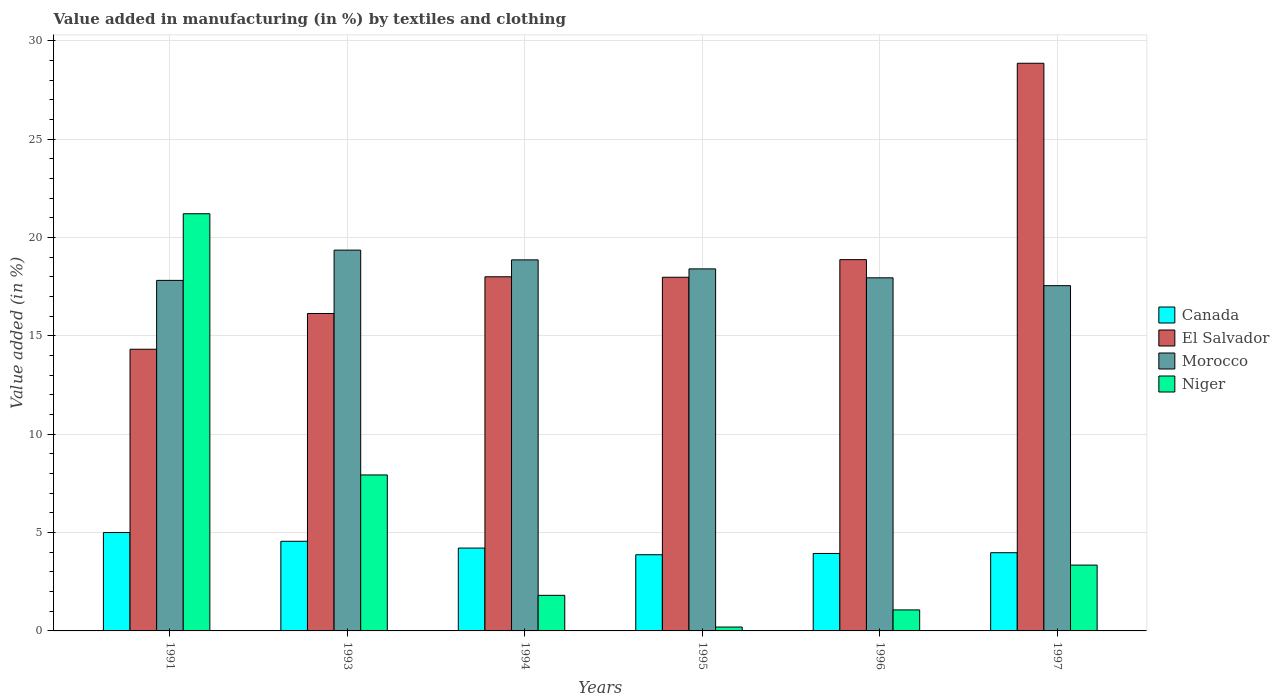How many different coloured bars are there?
Give a very brief answer. 4. How many groups of bars are there?
Your answer should be compact. 6. What is the label of the 2nd group of bars from the left?
Make the answer very short. 1993. What is the percentage of value added in manufacturing by textiles and clothing in El Salvador in 1994?
Give a very brief answer. 18.01. Across all years, what is the maximum percentage of value added in manufacturing by textiles and clothing in Canada?
Your answer should be compact. 5. Across all years, what is the minimum percentage of value added in manufacturing by textiles and clothing in Morocco?
Your answer should be very brief. 17.56. In which year was the percentage of value added in manufacturing by textiles and clothing in Niger maximum?
Your response must be concise. 1991. In which year was the percentage of value added in manufacturing by textiles and clothing in Morocco minimum?
Make the answer very short. 1997. What is the total percentage of value added in manufacturing by textiles and clothing in Niger in the graph?
Offer a terse response. 35.57. What is the difference between the percentage of value added in manufacturing by textiles and clothing in Canada in 1991 and that in 1995?
Keep it short and to the point. 1.13. What is the difference between the percentage of value added in manufacturing by textiles and clothing in Niger in 1997 and the percentage of value added in manufacturing by textiles and clothing in Canada in 1995?
Provide a short and direct response. -0.53. What is the average percentage of value added in manufacturing by textiles and clothing in Morocco per year?
Your answer should be compact. 18.33. In the year 1997, what is the difference between the percentage of value added in manufacturing by textiles and clothing in Morocco and percentage of value added in manufacturing by textiles and clothing in Niger?
Provide a short and direct response. 14.21. What is the ratio of the percentage of value added in manufacturing by textiles and clothing in El Salvador in 1991 to that in 1994?
Your answer should be very brief. 0.8. What is the difference between the highest and the second highest percentage of value added in manufacturing by textiles and clothing in Canada?
Offer a terse response. 0.44. What is the difference between the highest and the lowest percentage of value added in manufacturing by textiles and clothing in Morocco?
Offer a terse response. 1.81. In how many years, is the percentage of value added in manufacturing by textiles and clothing in Morocco greater than the average percentage of value added in manufacturing by textiles and clothing in Morocco taken over all years?
Ensure brevity in your answer.  3. Is it the case that in every year, the sum of the percentage of value added in manufacturing by textiles and clothing in El Salvador and percentage of value added in manufacturing by textiles and clothing in Niger is greater than the percentage of value added in manufacturing by textiles and clothing in Canada?
Offer a very short reply. Yes. How many years are there in the graph?
Your answer should be compact. 6. What is the difference between two consecutive major ticks on the Y-axis?
Make the answer very short. 5. Are the values on the major ticks of Y-axis written in scientific E-notation?
Your response must be concise. No. What is the title of the graph?
Your answer should be very brief. Value added in manufacturing (in %) by textiles and clothing. What is the label or title of the Y-axis?
Provide a short and direct response. Value added (in %). What is the Value added (in %) of Canada in 1991?
Offer a terse response. 5. What is the Value added (in %) in El Salvador in 1991?
Keep it short and to the point. 14.32. What is the Value added (in %) in Morocco in 1991?
Provide a succinct answer. 17.83. What is the Value added (in %) of Niger in 1991?
Your answer should be very brief. 21.21. What is the Value added (in %) of Canada in 1993?
Offer a terse response. 4.56. What is the Value added (in %) of El Salvador in 1993?
Make the answer very short. 16.14. What is the Value added (in %) of Morocco in 1993?
Your answer should be very brief. 19.36. What is the Value added (in %) of Niger in 1993?
Keep it short and to the point. 7.93. What is the Value added (in %) in Canada in 1994?
Your answer should be compact. 4.21. What is the Value added (in %) in El Salvador in 1994?
Ensure brevity in your answer.  18.01. What is the Value added (in %) in Morocco in 1994?
Your response must be concise. 18.87. What is the Value added (in %) in Niger in 1994?
Provide a short and direct response. 1.81. What is the Value added (in %) of Canada in 1995?
Offer a very short reply. 3.87. What is the Value added (in %) in El Salvador in 1995?
Your answer should be very brief. 17.98. What is the Value added (in %) in Morocco in 1995?
Your answer should be compact. 18.41. What is the Value added (in %) of Niger in 1995?
Offer a terse response. 0.2. What is the Value added (in %) of Canada in 1996?
Provide a short and direct response. 3.94. What is the Value added (in %) of El Salvador in 1996?
Make the answer very short. 18.88. What is the Value added (in %) of Morocco in 1996?
Make the answer very short. 17.96. What is the Value added (in %) in Niger in 1996?
Keep it short and to the point. 1.07. What is the Value added (in %) of Canada in 1997?
Ensure brevity in your answer.  3.98. What is the Value added (in %) in El Salvador in 1997?
Your answer should be compact. 28.87. What is the Value added (in %) in Morocco in 1997?
Provide a succinct answer. 17.56. What is the Value added (in %) of Niger in 1997?
Make the answer very short. 3.35. Across all years, what is the maximum Value added (in %) of Canada?
Ensure brevity in your answer.  5. Across all years, what is the maximum Value added (in %) in El Salvador?
Your answer should be very brief. 28.87. Across all years, what is the maximum Value added (in %) of Morocco?
Give a very brief answer. 19.36. Across all years, what is the maximum Value added (in %) in Niger?
Provide a succinct answer. 21.21. Across all years, what is the minimum Value added (in %) of Canada?
Provide a short and direct response. 3.87. Across all years, what is the minimum Value added (in %) in El Salvador?
Offer a very short reply. 14.32. Across all years, what is the minimum Value added (in %) in Morocco?
Provide a succinct answer. 17.56. Across all years, what is the minimum Value added (in %) of Niger?
Your answer should be very brief. 0.2. What is the total Value added (in %) in Canada in the graph?
Ensure brevity in your answer.  25.56. What is the total Value added (in %) in El Salvador in the graph?
Offer a terse response. 114.2. What is the total Value added (in %) in Morocco in the graph?
Offer a very short reply. 109.98. What is the total Value added (in %) of Niger in the graph?
Provide a short and direct response. 35.57. What is the difference between the Value added (in %) in Canada in 1991 and that in 1993?
Your response must be concise. 0.44. What is the difference between the Value added (in %) of El Salvador in 1991 and that in 1993?
Your answer should be very brief. -1.82. What is the difference between the Value added (in %) of Morocco in 1991 and that in 1993?
Your answer should be compact. -1.54. What is the difference between the Value added (in %) of Niger in 1991 and that in 1993?
Give a very brief answer. 13.28. What is the difference between the Value added (in %) of Canada in 1991 and that in 1994?
Make the answer very short. 0.79. What is the difference between the Value added (in %) of El Salvador in 1991 and that in 1994?
Give a very brief answer. -3.68. What is the difference between the Value added (in %) in Morocco in 1991 and that in 1994?
Provide a succinct answer. -1.04. What is the difference between the Value added (in %) of Niger in 1991 and that in 1994?
Keep it short and to the point. 19.4. What is the difference between the Value added (in %) in Canada in 1991 and that in 1995?
Offer a terse response. 1.13. What is the difference between the Value added (in %) in El Salvador in 1991 and that in 1995?
Ensure brevity in your answer.  -3.66. What is the difference between the Value added (in %) of Morocco in 1991 and that in 1995?
Your answer should be very brief. -0.58. What is the difference between the Value added (in %) of Niger in 1991 and that in 1995?
Give a very brief answer. 21.02. What is the difference between the Value added (in %) in Canada in 1991 and that in 1996?
Keep it short and to the point. 1.06. What is the difference between the Value added (in %) in El Salvador in 1991 and that in 1996?
Your answer should be very brief. -4.56. What is the difference between the Value added (in %) in Morocco in 1991 and that in 1996?
Keep it short and to the point. -0.13. What is the difference between the Value added (in %) in Niger in 1991 and that in 1996?
Offer a very short reply. 20.15. What is the difference between the Value added (in %) in El Salvador in 1991 and that in 1997?
Your response must be concise. -14.54. What is the difference between the Value added (in %) of Morocco in 1991 and that in 1997?
Offer a terse response. 0.27. What is the difference between the Value added (in %) in Niger in 1991 and that in 1997?
Offer a terse response. 17.87. What is the difference between the Value added (in %) in Canada in 1993 and that in 1994?
Make the answer very short. 0.35. What is the difference between the Value added (in %) in El Salvador in 1993 and that in 1994?
Give a very brief answer. -1.87. What is the difference between the Value added (in %) in Morocco in 1993 and that in 1994?
Give a very brief answer. 0.5. What is the difference between the Value added (in %) in Niger in 1993 and that in 1994?
Offer a terse response. 6.12. What is the difference between the Value added (in %) in Canada in 1993 and that in 1995?
Your answer should be very brief. 0.68. What is the difference between the Value added (in %) of El Salvador in 1993 and that in 1995?
Your answer should be compact. -1.84. What is the difference between the Value added (in %) of Morocco in 1993 and that in 1995?
Your response must be concise. 0.95. What is the difference between the Value added (in %) of Niger in 1993 and that in 1995?
Make the answer very short. 7.73. What is the difference between the Value added (in %) of Canada in 1993 and that in 1996?
Offer a terse response. 0.62. What is the difference between the Value added (in %) in El Salvador in 1993 and that in 1996?
Offer a very short reply. -2.74. What is the difference between the Value added (in %) in Morocco in 1993 and that in 1996?
Provide a succinct answer. 1.41. What is the difference between the Value added (in %) in Niger in 1993 and that in 1996?
Your answer should be compact. 6.86. What is the difference between the Value added (in %) in Canada in 1993 and that in 1997?
Offer a very short reply. 0.58. What is the difference between the Value added (in %) of El Salvador in 1993 and that in 1997?
Provide a succinct answer. -12.72. What is the difference between the Value added (in %) of Morocco in 1993 and that in 1997?
Make the answer very short. 1.81. What is the difference between the Value added (in %) in Niger in 1993 and that in 1997?
Offer a very short reply. 4.58. What is the difference between the Value added (in %) in Canada in 1994 and that in 1995?
Offer a terse response. 0.34. What is the difference between the Value added (in %) of El Salvador in 1994 and that in 1995?
Your answer should be compact. 0.02. What is the difference between the Value added (in %) of Morocco in 1994 and that in 1995?
Offer a terse response. 0.46. What is the difference between the Value added (in %) of Niger in 1994 and that in 1995?
Your answer should be very brief. 1.61. What is the difference between the Value added (in %) in Canada in 1994 and that in 1996?
Provide a short and direct response. 0.27. What is the difference between the Value added (in %) of El Salvador in 1994 and that in 1996?
Make the answer very short. -0.87. What is the difference between the Value added (in %) of Morocco in 1994 and that in 1996?
Offer a very short reply. 0.91. What is the difference between the Value added (in %) in Niger in 1994 and that in 1996?
Provide a succinct answer. 0.74. What is the difference between the Value added (in %) in Canada in 1994 and that in 1997?
Your response must be concise. 0.24. What is the difference between the Value added (in %) in El Salvador in 1994 and that in 1997?
Make the answer very short. -10.86. What is the difference between the Value added (in %) of Morocco in 1994 and that in 1997?
Provide a succinct answer. 1.31. What is the difference between the Value added (in %) of Niger in 1994 and that in 1997?
Provide a succinct answer. -1.54. What is the difference between the Value added (in %) in Canada in 1995 and that in 1996?
Give a very brief answer. -0.07. What is the difference between the Value added (in %) in El Salvador in 1995 and that in 1996?
Your response must be concise. -0.9. What is the difference between the Value added (in %) of Morocco in 1995 and that in 1996?
Keep it short and to the point. 0.45. What is the difference between the Value added (in %) in Niger in 1995 and that in 1996?
Give a very brief answer. -0.87. What is the difference between the Value added (in %) in Canada in 1995 and that in 1997?
Your answer should be very brief. -0.1. What is the difference between the Value added (in %) in El Salvador in 1995 and that in 1997?
Keep it short and to the point. -10.88. What is the difference between the Value added (in %) of Morocco in 1995 and that in 1997?
Your response must be concise. 0.85. What is the difference between the Value added (in %) in Niger in 1995 and that in 1997?
Your answer should be compact. -3.15. What is the difference between the Value added (in %) in Canada in 1996 and that in 1997?
Offer a terse response. -0.04. What is the difference between the Value added (in %) in El Salvador in 1996 and that in 1997?
Give a very brief answer. -9.99. What is the difference between the Value added (in %) in Morocco in 1996 and that in 1997?
Offer a terse response. 0.4. What is the difference between the Value added (in %) of Niger in 1996 and that in 1997?
Offer a very short reply. -2.28. What is the difference between the Value added (in %) of Canada in 1991 and the Value added (in %) of El Salvador in 1993?
Offer a terse response. -11.14. What is the difference between the Value added (in %) in Canada in 1991 and the Value added (in %) in Morocco in 1993?
Provide a short and direct response. -14.36. What is the difference between the Value added (in %) of Canada in 1991 and the Value added (in %) of Niger in 1993?
Offer a very short reply. -2.93. What is the difference between the Value added (in %) in El Salvador in 1991 and the Value added (in %) in Morocco in 1993?
Give a very brief answer. -5.04. What is the difference between the Value added (in %) of El Salvador in 1991 and the Value added (in %) of Niger in 1993?
Keep it short and to the point. 6.39. What is the difference between the Value added (in %) in Morocco in 1991 and the Value added (in %) in Niger in 1993?
Provide a short and direct response. 9.89. What is the difference between the Value added (in %) in Canada in 1991 and the Value added (in %) in El Salvador in 1994?
Your answer should be very brief. -13.01. What is the difference between the Value added (in %) in Canada in 1991 and the Value added (in %) in Morocco in 1994?
Your answer should be very brief. -13.87. What is the difference between the Value added (in %) in Canada in 1991 and the Value added (in %) in Niger in 1994?
Your answer should be very brief. 3.19. What is the difference between the Value added (in %) of El Salvador in 1991 and the Value added (in %) of Morocco in 1994?
Offer a terse response. -4.54. What is the difference between the Value added (in %) in El Salvador in 1991 and the Value added (in %) in Niger in 1994?
Offer a terse response. 12.51. What is the difference between the Value added (in %) of Morocco in 1991 and the Value added (in %) of Niger in 1994?
Provide a succinct answer. 16.02. What is the difference between the Value added (in %) in Canada in 1991 and the Value added (in %) in El Salvador in 1995?
Provide a short and direct response. -12.98. What is the difference between the Value added (in %) of Canada in 1991 and the Value added (in %) of Morocco in 1995?
Provide a short and direct response. -13.41. What is the difference between the Value added (in %) of Canada in 1991 and the Value added (in %) of Niger in 1995?
Ensure brevity in your answer.  4.81. What is the difference between the Value added (in %) of El Salvador in 1991 and the Value added (in %) of Morocco in 1995?
Offer a terse response. -4.09. What is the difference between the Value added (in %) in El Salvador in 1991 and the Value added (in %) in Niger in 1995?
Your response must be concise. 14.13. What is the difference between the Value added (in %) in Morocco in 1991 and the Value added (in %) in Niger in 1995?
Your answer should be compact. 17.63. What is the difference between the Value added (in %) in Canada in 1991 and the Value added (in %) in El Salvador in 1996?
Offer a very short reply. -13.88. What is the difference between the Value added (in %) in Canada in 1991 and the Value added (in %) in Morocco in 1996?
Ensure brevity in your answer.  -12.95. What is the difference between the Value added (in %) of Canada in 1991 and the Value added (in %) of Niger in 1996?
Offer a very short reply. 3.93. What is the difference between the Value added (in %) of El Salvador in 1991 and the Value added (in %) of Morocco in 1996?
Provide a short and direct response. -3.63. What is the difference between the Value added (in %) of El Salvador in 1991 and the Value added (in %) of Niger in 1996?
Your answer should be very brief. 13.26. What is the difference between the Value added (in %) of Morocco in 1991 and the Value added (in %) of Niger in 1996?
Give a very brief answer. 16.76. What is the difference between the Value added (in %) of Canada in 1991 and the Value added (in %) of El Salvador in 1997?
Make the answer very short. -23.86. What is the difference between the Value added (in %) in Canada in 1991 and the Value added (in %) in Morocco in 1997?
Provide a succinct answer. -12.55. What is the difference between the Value added (in %) of Canada in 1991 and the Value added (in %) of Niger in 1997?
Your answer should be compact. 1.65. What is the difference between the Value added (in %) in El Salvador in 1991 and the Value added (in %) in Morocco in 1997?
Offer a very short reply. -3.23. What is the difference between the Value added (in %) of El Salvador in 1991 and the Value added (in %) of Niger in 1997?
Provide a short and direct response. 10.98. What is the difference between the Value added (in %) of Morocco in 1991 and the Value added (in %) of Niger in 1997?
Your answer should be compact. 14.48. What is the difference between the Value added (in %) in Canada in 1993 and the Value added (in %) in El Salvador in 1994?
Keep it short and to the point. -13.45. What is the difference between the Value added (in %) in Canada in 1993 and the Value added (in %) in Morocco in 1994?
Provide a succinct answer. -14.31. What is the difference between the Value added (in %) in Canada in 1993 and the Value added (in %) in Niger in 1994?
Give a very brief answer. 2.75. What is the difference between the Value added (in %) in El Salvador in 1993 and the Value added (in %) in Morocco in 1994?
Provide a succinct answer. -2.73. What is the difference between the Value added (in %) of El Salvador in 1993 and the Value added (in %) of Niger in 1994?
Provide a short and direct response. 14.33. What is the difference between the Value added (in %) in Morocco in 1993 and the Value added (in %) in Niger in 1994?
Offer a terse response. 17.55. What is the difference between the Value added (in %) in Canada in 1993 and the Value added (in %) in El Salvador in 1995?
Offer a very short reply. -13.43. What is the difference between the Value added (in %) of Canada in 1993 and the Value added (in %) of Morocco in 1995?
Provide a succinct answer. -13.85. What is the difference between the Value added (in %) of Canada in 1993 and the Value added (in %) of Niger in 1995?
Keep it short and to the point. 4.36. What is the difference between the Value added (in %) of El Salvador in 1993 and the Value added (in %) of Morocco in 1995?
Give a very brief answer. -2.27. What is the difference between the Value added (in %) of El Salvador in 1993 and the Value added (in %) of Niger in 1995?
Make the answer very short. 15.94. What is the difference between the Value added (in %) of Morocco in 1993 and the Value added (in %) of Niger in 1995?
Your answer should be very brief. 19.17. What is the difference between the Value added (in %) of Canada in 1993 and the Value added (in %) of El Salvador in 1996?
Give a very brief answer. -14.32. What is the difference between the Value added (in %) of Canada in 1993 and the Value added (in %) of Morocco in 1996?
Offer a very short reply. -13.4. What is the difference between the Value added (in %) of Canada in 1993 and the Value added (in %) of Niger in 1996?
Make the answer very short. 3.49. What is the difference between the Value added (in %) of El Salvador in 1993 and the Value added (in %) of Morocco in 1996?
Ensure brevity in your answer.  -1.81. What is the difference between the Value added (in %) of El Salvador in 1993 and the Value added (in %) of Niger in 1996?
Give a very brief answer. 15.07. What is the difference between the Value added (in %) in Morocco in 1993 and the Value added (in %) in Niger in 1996?
Keep it short and to the point. 18.3. What is the difference between the Value added (in %) of Canada in 1993 and the Value added (in %) of El Salvador in 1997?
Provide a succinct answer. -24.31. What is the difference between the Value added (in %) of Canada in 1993 and the Value added (in %) of Morocco in 1997?
Give a very brief answer. -13. What is the difference between the Value added (in %) in Canada in 1993 and the Value added (in %) in Niger in 1997?
Make the answer very short. 1.21. What is the difference between the Value added (in %) in El Salvador in 1993 and the Value added (in %) in Morocco in 1997?
Your answer should be compact. -1.42. What is the difference between the Value added (in %) in El Salvador in 1993 and the Value added (in %) in Niger in 1997?
Keep it short and to the point. 12.79. What is the difference between the Value added (in %) in Morocco in 1993 and the Value added (in %) in Niger in 1997?
Your response must be concise. 16.02. What is the difference between the Value added (in %) in Canada in 1994 and the Value added (in %) in El Salvador in 1995?
Offer a very short reply. -13.77. What is the difference between the Value added (in %) in Canada in 1994 and the Value added (in %) in Morocco in 1995?
Your answer should be very brief. -14.2. What is the difference between the Value added (in %) of Canada in 1994 and the Value added (in %) of Niger in 1995?
Give a very brief answer. 4.02. What is the difference between the Value added (in %) of El Salvador in 1994 and the Value added (in %) of Morocco in 1995?
Give a very brief answer. -0.4. What is the difference between the Value added (in %) in El Salvador in 1994 and the Value added (in %) in Niger in 1995?
Ensure brevity in your answer.  17.81. What is the difference between the Value added (in %) in Morocco in 1994 and the Value added (in %) in Niger in 1995?
Offer a terse response. 18.67. What is the difference between the Value added (in %) of Canada in 1994 and the Value added (in %) of El Salvador in 1996?
Your answer should be compact. -14.67. What is the difference between the Value added (in %) of Canada in 1994 and the Value added (in %) of Morocco in 1996?
Give a very brief answer. -13.74. What is the difference between the Value added (in %) in Canada in 1994 and the Value added (in %) in Niger in 1996?
Make the answer very short. 3.15. What is the difference between the Value added (in %) in El Salvador in 1994 and the Value added (in %) in Morocco in 1996?
Offer a terse response. 0.05. What is the difference between the Value added (in %) in El Salvador in 1994 and the Value added (in %) in Niger in 1996?
Give a very brief answer. 16.94. What is the difference between the Value added (in %) in Morocco in 1994 and the Value added (in %) in Niger in 1996?
Your answer should be compact. 17.8. What is the difference between the Value added (in %) of Canada in 1994 and the Value added (in %) of El Salvador in 1997?
Provide a short and direct response. -24.65. What is the difference between the Value added (in %) of Canada in 1994 and the Value added (in %) of Morocco in 1997?
Your answer should be compact. -13.34. What is the difference between the Value added (in %) of Canada in 1994 and the Value added (in %) of Niger in 1997?
Give a very brief answer. 0.87. What is the difference between the Value added (in %) in El Salvador in 1994 and the Value added (in %) in Morocco in 1997?
Make the answer very short. 0.45. What is the difference between the Value added (in %) in El Salvador in 1994 and the Value added (in %) in Niger in 1997?
Ensure brevity in your answer.  14.66. What is the difference between the Value added (in %) of Morocco in 1994 and the Value added (in %) of Niger in 1997?
Make the answer very short. 15.52. What is the difference between the Value added (in %) in Canada in 1995 and the Value added (in %) in El Salvador in 1996?
Give a very brief answer. -15.01. What is the difference between the Value added (in %) of Canada in 1995 and the Value added (in %) of Morocco in 1996?
Keep it short and to the point. -14.08. What is the difference between the Value added (in %) of Canada in 1995 and the Value added (in %) of Niger in 1996?
Provide a succinct answer. 2.81. What is the difference between the Value added (in %) in El Salvador in 1995 and the Value added (in %) in Morocco in 1996?
Keep it short and to the point. 0.03. What is the difference between the Value added (in %) in El Salvador in 1995 and the Value added (in %) in Niger in 1996?
Ensure brevity in your answer.  16.92. What is the difference between the Value added (in %) in Morocco in 1995 and the Value added (in %) in Niger in 1996?
Your answer should be very brief. 17.34. What is the difference between the Value added (in %) in Canada in 1995 and the Value added (in %) in El Salvador in 1997?
Offer a terse response. -24.99. What is the difference between the Value added (in %) of Canada in 1995 and the Value added (in %) of Morocco in 1997?
Offer a very short reply. -13.68. What is the difference between the Value added (in %) in Canada in 1995 and the Value added (in %) in Niger in 1997?
Your answer should be very brief. 0.53. What is the difference between the Value added (in %) of El Salvador in 1995 and the Value added (in %) of Morocco in 1997?
Make the answer very short. 0.43. What is the difference between the Value added (in %) of El Salvador in 1995 and the Value added (in %) of Niger in 1997?
Ensure brevity in your answer.  14.64. What is the difference between the Value added (in %) of Morocco in 1995 and the Value added (in %) of Niger in 1997?
Make the answer very short. 15.06. What is the difference between the Value added (in %) in Canada in 1996 and the Value added (in %) in El Salvador in 1997?
Offer a very short reply. -24.93. What is the difference between the Value added (in %) of Canada in 1996 and the Value added (in %) of Morocco in 1997?
Offer a terse response. -13.62. What is the difference between the Value added (in %) in Canada in 1996 and the Value added (in %) in Niger in 1997?
Your answer should be compact. 0.59. What is the difference between the Value added (in %) of El Salvador in 1996 and the Value added (in %) of Morocco in 1997?
Give a very brief answer. 1.32. What is the difference between the Value added (in %) in El Salvador in 1996 and the Value added (in %) in Niger in 1997?
Ensure brevity in your answer.  15.53. What is the difference between the Value added (in %) of Morocco in 1996 and the Value added (in %) of Niger in 1997?
Ensure brevity in your answer.  14.61. What is the average Value added (in %) in Canada per year?
Keep it short and to the point. 4.26. What is the average Value added (in %) in El Salvador per year?
Ensure brevity in your answer.  19.03. What is the average Value added (in %) of Morocco per year?
Provide a succinct answer. 18.33. What is the average Value added (in %) in Niger per year?
Ensure brevity in your answer.  5.93. In the year 1991, what is the difference between the Value added (in %) in Canada and Value added (in %) in El Salvador?
Give a very brief answer. -9.32. In the year 1991, what is the difference between the Value added (in %) in Canada and Value added (in %) in Morocco?
Make the answer very short. -12.82. In the year 1991, what is the difference between the Value added (in %) of Canada and Value added (in %) of Niger?
Your response must be concise. -16.21. In the year 1991, what is the difference between the Value added (in %) in El Salvador and Value added (in %) in Morocco?
Your response must be concise. -3.5. In the year 1991, what is the difference between the Value added (in %) in El Salvador and Value added (in %) in Niger?
Provide a succinct answer. -6.89. In the year 1991, what is the difference between the Value added (in %) in Morocco and Value added (in %) in Niger?
Offer a very short reply. -3.39. In the year 1993, what is the difference between the Value added (in %) in Canada and Value added (in %) in El Salvador?
Provide a succinct answer. -11.58. In the year 1993, what is the difference between the Value added (in %) of Canada and Value added (in %) of Morocco?
Give a very brief answer. -14.8. In the year 1993, what is the difference between the Value added (in %) of Canada and Value added (in %) of Niger?
Your answer should be very brief. -3.37. In the year 1993, what is the difference between the Value added (in %) of El Salvador and Value added (in %) of Morocco?
Offer a very short reply. -3.22. In the year 1993, what is the difference between the Value added (in %) in El Salvador and Value added (in %) in Niger?
Offer a very short reply. 8.21. In the year 1993, what is the difference between the Value added (in %) in Morocco and Value added (in %) in Niger?
Your response must be concise. 11.43. In the year 1994, what is the difference between the Value added (in %) in Canada and Value added (in %) in El Salvador?
Your response must be concise. -13.8. In the year 1994, what is the difference between the Value added (in %) of Canada and Value added (in %) of Morocco?
Provide a succinct answer. -14.65. In the year 1994, what is the difference between the Value added (in %) in Canada and Value added (in %) in Niger?
Ensure brevity in your answer.  2.4. In the year 1994, what is the difference between the Value added (in %) of El Salvador and Value added (in %) of Morocco?
Provide a succinct answer. -0.86. In the year 1994, what is the difference between the Value added (in %) in El Salvador and Value added (in %) in Niger?
Your response must be concise. 16.2. In the year 1994, what is the difference between the Value added (in %) in Morocco and Value added (in %) in Niger?
Provide a succinct answer. 17.06. In the year 1995, what is the difference between the Value added (in %) of Canada and Value added (in %) of El Salvador?
Provide a succinct answer. -14.11. In the year 1995, what is the difference between the Value added (in %) in Canada and Value added (in %) in Morocco?
Keep it short and to the point. -14.54. In the year 1995, what is the difference between the Value added (in %) in Canada and Value added (in %) in Niger?
Offer a terse response. 3.68. In the year 1995, what is the difference between the Value added (in %) of El Salvador and Value added (in %) of Morocco?
Ensure brevity in your answer.  -0.43. In the year 1995, what is the difference between the Value added (in %) of El Salvador and Value added (in %) of Niger?
Offer a terse response. 17.79. In the year 1995, what is the difference between the Value added (in %) of Morocco and Value added (in %) of Niger?
Give a very brief answer. 18.21. In the year 1996, what is the difference between the Value added (in %) in Canada and Value added (in %) in El Salvador?
Offer a terse response. -14.94. In the year 1996, what is the difference between the Value added (in %) in Canada and Value added (in %) in Morocco?
Your response must be concise. -14.02. In the year 1996, what is the difference between the Value added (in %) in Canada and Value added (in %) in Niger?
Your answer should be very brief. 2.87. In the year 1996, what is the difference between the Value added (in %) of El Salvador and Value added (in %) of Morocco?
Give a very brief answer. 0.92. In the year 1996, what is the difference between the Value added (in %) in El Salvador and Value added (in %) in Niger?
Provide a succinct answer. 17.81. In the year 1996, what is the difference between the Value added (in %) in Morocco and Value added (in %) in Niger?
Ensure brevity in your answer.  16.89. In the year 1997, what is the difference between the Value added (in %) of Canada and Value added (in %) of El Salvador?
Keep it short and to the point. -24.89. In the year 1997, what is the difference between the Value added (in %) of Canada and Value added (in %) of Morocco?
Give a very brief answer. -13.58. In the year 1997, what is the difference between the Value added (in %) in Canada and Value added (in %) in Niger?
Your answer should be compact. 0.63. In the year 1997, what is the difference between the Value added (in %) in El Salvador and Value added (in %) in Morocco?
Make the answer very short. 11.31. In the year 1997, what is the difference between the Value added (in %) in El Salvador and Value added (in %) in Niger?
Provide a short and direct response. 25.52. In the year 1997, what is the difference between the Value added (in %) of Morocco and Value added (in %) of Niger?
Your response must be concise. 14.21. What is the ratio of the Value added (in %) in Canada in 1991 to that in 1993?
Your response must be concise. 1.1. What is the ratio of the Value added (in %) of El Salvador in 1991 to that in 1993?
Provide a succinct answer. 0.89. What is the ratio of the Value added (in %) in Morocco in 1991 to that in 1993?
Ensure brevity in your answer.  0.92. What is the ratio of the Value added (in %) of Niger in 1991 to that in 1993?
Your response must be concise. 2.67. What is the ratio of the Value added (in %) in Canada in 1991 to that in 1994?
Offer a very short reply. 1.19. What is the ratio of the Value added (in %) of El Salvador in 1991 to that in 1994?
Offer a terse response. 0.8. What is the ratio of the Value added (in %) of Morocco in 1991 to that in 1994?
Provide a short and direct response. 0.94. What is the ratio of the Value added (in %) of Niger in 1991 to that in 1994?
Ensure brevity in your answer.  11.73. What is the ratio of the Value added (in %) of Canada in 1991 to that in 1995?
Make the answer very short. 1.29. What is the ratio of the Value added (in %) of El Salvador in 1991 to that in 1995?
Provide a succinct answer. 0.8. What is the ratio of the Value added (in %) in Morocco in 1991 to that in 1995?
Ensure brevity in your answer.  0.97. What is the ratio of the Value added (in %) in Niger in 1991 to that in 1995?
Provide a succinct answer. 107.32. What is the ratio of the Value added (in %) of Canada in 1991 to that in 1996?
Your answer should be very brief. 1.27. What is the ratio of the Value added (in %) of El Salvador in 1991 to that in 1996?
Your response must be concise. 0.76. What is the ratio of the Value added (in %) of Morocco in 1991 to that in 1996?
Keep it short and to the point. 0.99. What is the ratio of the Value added (in %) of Niger in 1991 to that in 1996?
Keep it short and to the point. 19.86. What is the ratio of the Value added (in %) in Canada in 1991 to that in 1997?
Your answer should be compact. 1.26. What is the ratio of the Value added (in %) of El Salvador in 1991 to that in 1997?
Offer a very short reply. 0.5. What is the ratio of the Value added (in %) of Morocco in 1991 to that in 1997?
Ensure brevity in your answer.  1.02. What is the ratio of the Value added (in %) of Niger in 1991 to that in 1997?
Ensure brevity in your answer.  6.34. What is the ratio of the Value added (in %) in Canada in 1993 to that in 1994?
Offer a very short reply. 1.08. What is the ratio of the Value added (in %) of El Salvador in 1993 to that in 1994?
Ensure brevity in your answer.  0.9. What is the ratio of the Value added (in %) of Morocco in 1993 to that in 1994?
Your response must be concise. 1.03. What is the ratio of the Value added (in %) of Niger in 1993 to that in 1994?
Your response must be concise. 4.38. What is the ratio of the Value added (in %) in Canada in 1993 to that in 1995?
Make the answer very short. 1.18. What is the ratio of the Value added (in %) in El Salvador in 1993 to that in 1995?
Provide a succinct answer. 0.9. What is the ratio of the Value added (in %) in Morocco in 1993 to that in 1995?
Your response must be concise. 1.05. What is the ratio of the Value added (in %) in Niger in 1993 to that in 1995?
Keep it short and to the point. 40.12. What is the ratio of the Value added (in %) in Canada in 1993 to that in 1996?
Give a very brief answer. 1.16. What is the ratio of the Value added (in %) in El Salvador in 1993 to that in 1996?
Keep it short and to the point. 0.85. What is the ratio of the Value added (in %) of Morocco in 1993 to that in 1996?
Ensure brevity in your answer.  1.08. What is the ratio of the Value added (in %) of Niger in 1993 to that in 1996?
Keep it short and to the point. 7.43. What is the ratio of the Value added (in %) in Canada in 1993 to that in 1997?
Provide a succinct answer. 1.15. What is the ratio of the Value added (in %) in El Salvador in 1993 to that in 1997?
Your response must be concise. 0.56. What is the ratio of the Value added (in %) of Morocco in 1993 to that in 1997?
Your response must be concise. 1.1. What is the ratio of the Value added (in %) in Niger in 1993 to that in 1997?
Give a very brief answer. 2.37. What is the ratio of the Value added (in %) in Canada in 1994 to that in 1995?
Provide a succinct answer. 1.09. What is the ratio of the Value added (in %) of Morocco in 1994 to that in 1995?
Offer a terse response. 1.02. What is the ratio of the Value added (in %) of Niger in 1994 to that in 1995?
Ensure brevity in your answer.  9.15. What is the ratio of the Value added (in %) of Canada in 1994 to that in 1996?
Make the answer very short. 1.07. What is the ratio of the Value added (in %) of El Salvador in 1994 to that in 1996?
Provide a succinct answer. 0.95. What is the ratio of the Value added (in %) of Morocco in 1994 to that in 1996?
Offer a terse response. 1.05. What is the ratio of the Value added (in %) in Niger in 1994 to that in 1996?
Make the answer very short. 1.69. What is the ratio of the Value added (in %) of Canada in 1994 to that in 1997?
Ensure brevity in your answer.  1.06. What is the ratio of the Value added (in %) in El Salvador in 1994 to that in 1997?
Offer a very short reply. 0.62. What is the ratio of the Value added (in %) of Morocco in 1994 to that in 1997?
Provide a succinct answer. 1.07. What is the ratio of the Value added (in %) of Niger in 1994 to that in 1997?
Make the answer very short. 0.54. What is the ratio of the Value added (in %) of Canada in 1995 to that in 1996?
Keep it short and to the point. 0.98. What is the ratio of the Value added (in %) in El Salvador in 1995 to that in 1996?
Offer a very short reply. 0.95. What is the ratio of the Value added (in %) in Morocco in 1995 to that in 1996?
Your response must be concise. 1.03. What is the ratio of the Value added (in %) of Niger in 1995 to that in 1996?
Your answer should be compact. 0.19. What is the ratio of the Value added (in %) of Canada in 1995 to that in 1997?
Ensure brevity in your answer.  0.97. What is the ratio of the Value added (in %) in El Salvador in 1995 to that in 1997?
Give a very brief answer. 0.62. What is the ratio of the Value added (in %) of Morocco in 1995 to that in 1997?
Ensure brevity in your answer.  1.05. What is the ratio of the Value added (in %) of Niger in 1995 to that in 1997?
Provide a short and direct response. 0.06. What is the ratio of the Value added (in %) in Canada in 1996 to that in 1997?
Keep it short and to the point. 0.99. What is the ratio of the Value added (in %) of El Salvador in 1996 to that in 1997?
Your response must be concise. 0.65. What is the ratio of the Value added (in %) of Morocco in 1996 to that in 1997?
Give a very brief answer. 1.02. What is the ratio of the Value added (in %) of Niger in 1996 to that in 1997?
Give a very brief answer. 0.32. What is the difference between the highest and the second highest Value added (in %) in Canada?
Offer a very short reply. 0.44. What is the difference between the highest and the second highest Value added (in %) of El Salvador?
Make the answer very short. 9.99. What is the difference between the highest and the second highest Value added (in %) in Morocco?
Make the answer very short. 0.5. What is the difference between the highest and the second highest Value added (in %) in Niger?
Ensure brevity in your answer.  13.28. What is the difference between the highest and the lowest Value added (in %) of Canada?
Your answer should be compact. 1.13. What is the difference between the highest and the lowest Value added (in %) in El Salvador?
Your answer should be compact. 14.54. What is the difference between the highest and the lowest Value added (in %) in Morocco?
Offer a very short reply. 1.81. What is the difference between the highest and the lowest Value added (in %) of Niger?
Give a very brief answer. 21.02. 